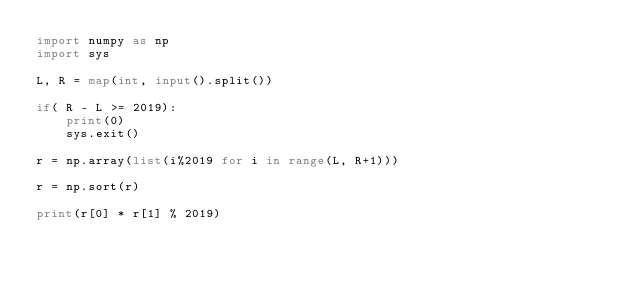<code> <loc_0><loc_0><loc_500><loc_500><_Python_>import numpy as np
import sys

L, R = map(int, input().split())

if( R - L >= 2019):
    print(0)
    sys.exit()

r = np.array(list(i%2019 for i in range(L, R+1)))

r = np.sort(r)

print(r[0] * r[1] % 2019)
</code> 